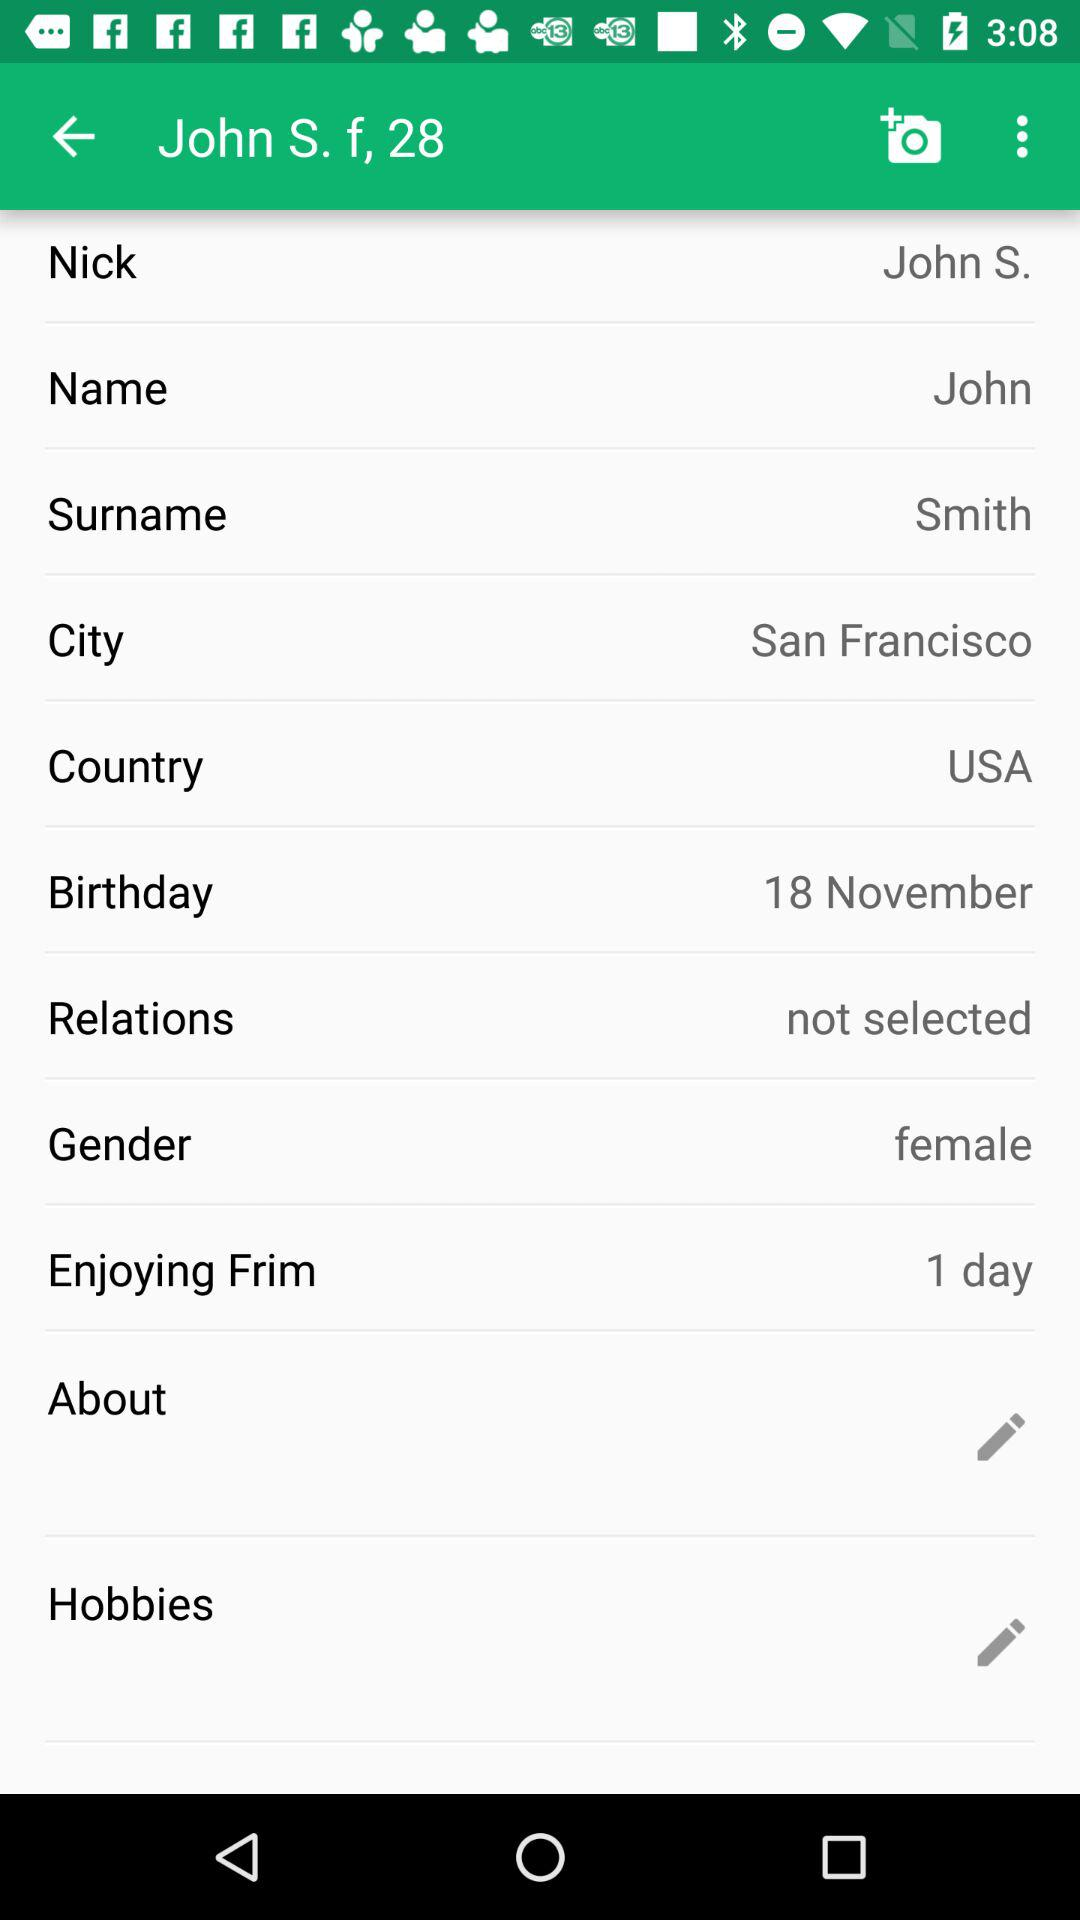Which city is given? The given city is San Francisco. 